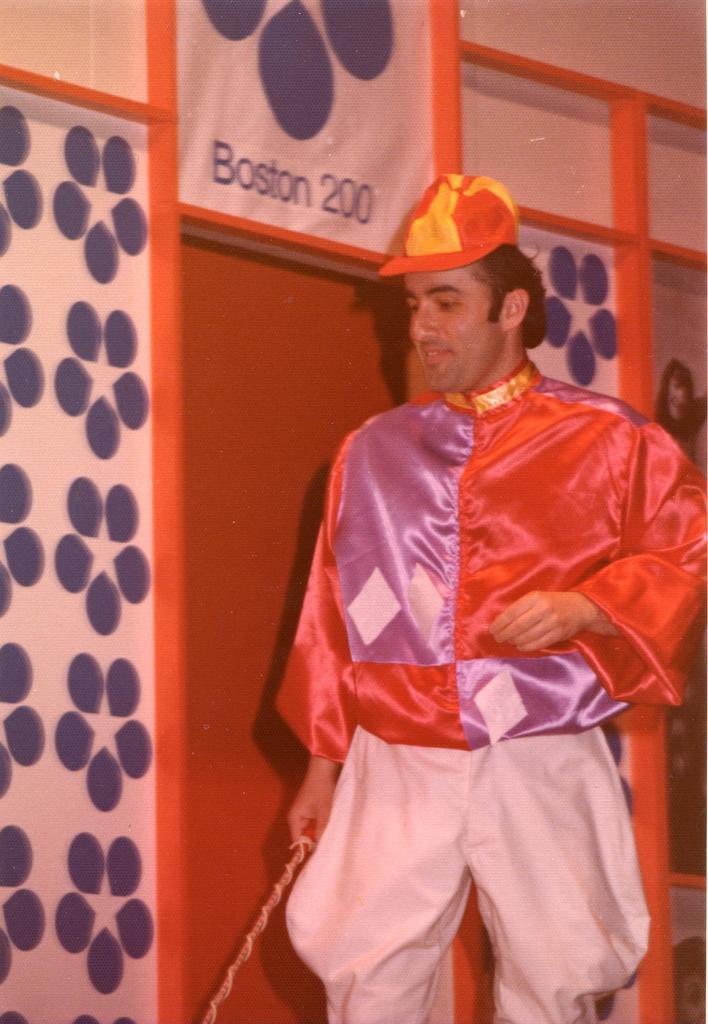Can you describe this image briefly? The person wearing fancy dress is standing and there is a door beside him. 